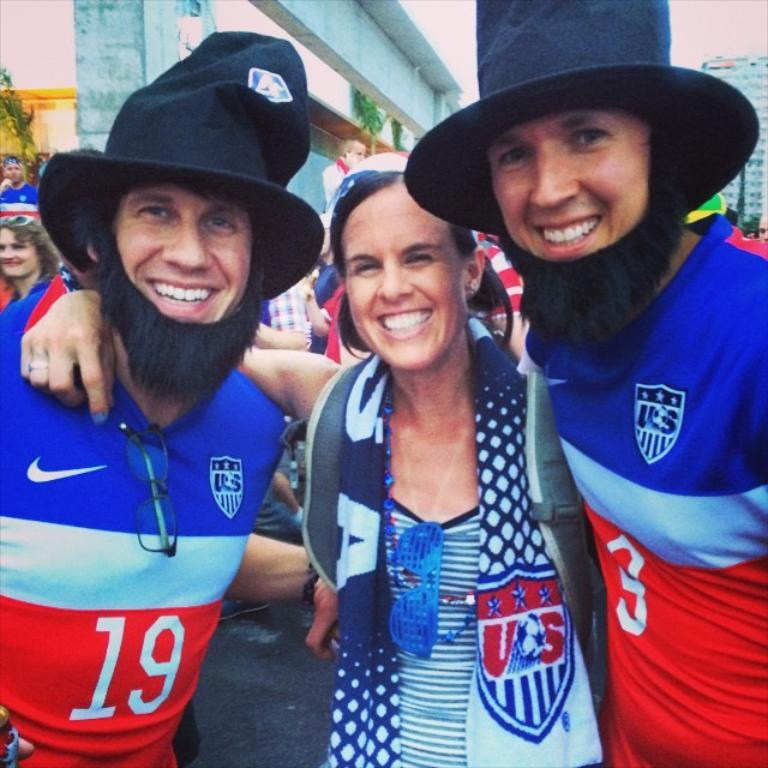Where was the image taken? The image was taken outside a city. What can be seen in the foreground of the image? There are people on the roads in the foreground of the image. What is visible in the background of the image? There are buildings and trees in the background of the image. What reason did the representative give for pulling the lever in the image? There is no representative or lever present in the image, so it is not possible to answer that question. 